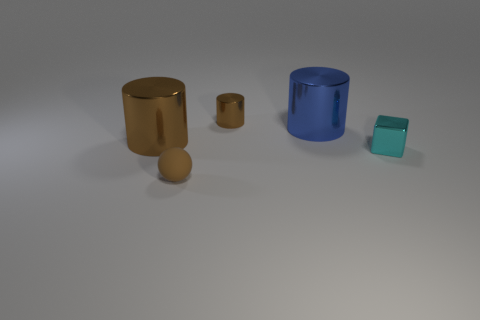Does the tiny matte sphere have the same color as the tiny cylinder?
Make the answer very short. Yes. There is a blue cylinder that is made of the same material as the large brown object; what is its size?
Keep it short and to the point. Large. Is the number of brown cylinders that are on the left side of the tiny brown metal cylinder greater than the number of yellow cubes?
Your answer should be compact. Yes. Does the big blue metallic object have the same shape as the tiny brown thing behind the cyan object?
Give a very brief answer. Yes. How many tiny objects are red metal balls or cyan metal cubes?
Make the answer very short. 1. There is another cylinder that is the same color as the small metal cylinder; what size is it?
Keep it short and to the point. Large. What is the color of the shiny object in front of the big metallic cylinder on the left side of the large blue cylinder?
Provide a short and direct response. Cyan. Is the big blue object made of the same material as the small brown thing behind the tiny cyan object?
Give a very brief answer. Yes. What is the material of the small cyan object right of the tiny brown cylinder?
Ensure brevity in your answer.  Metal. Are there the same number of cyan cubes that are to the left of the blue metal cylinder and large green things?
Offer a very short reply. Yes. 